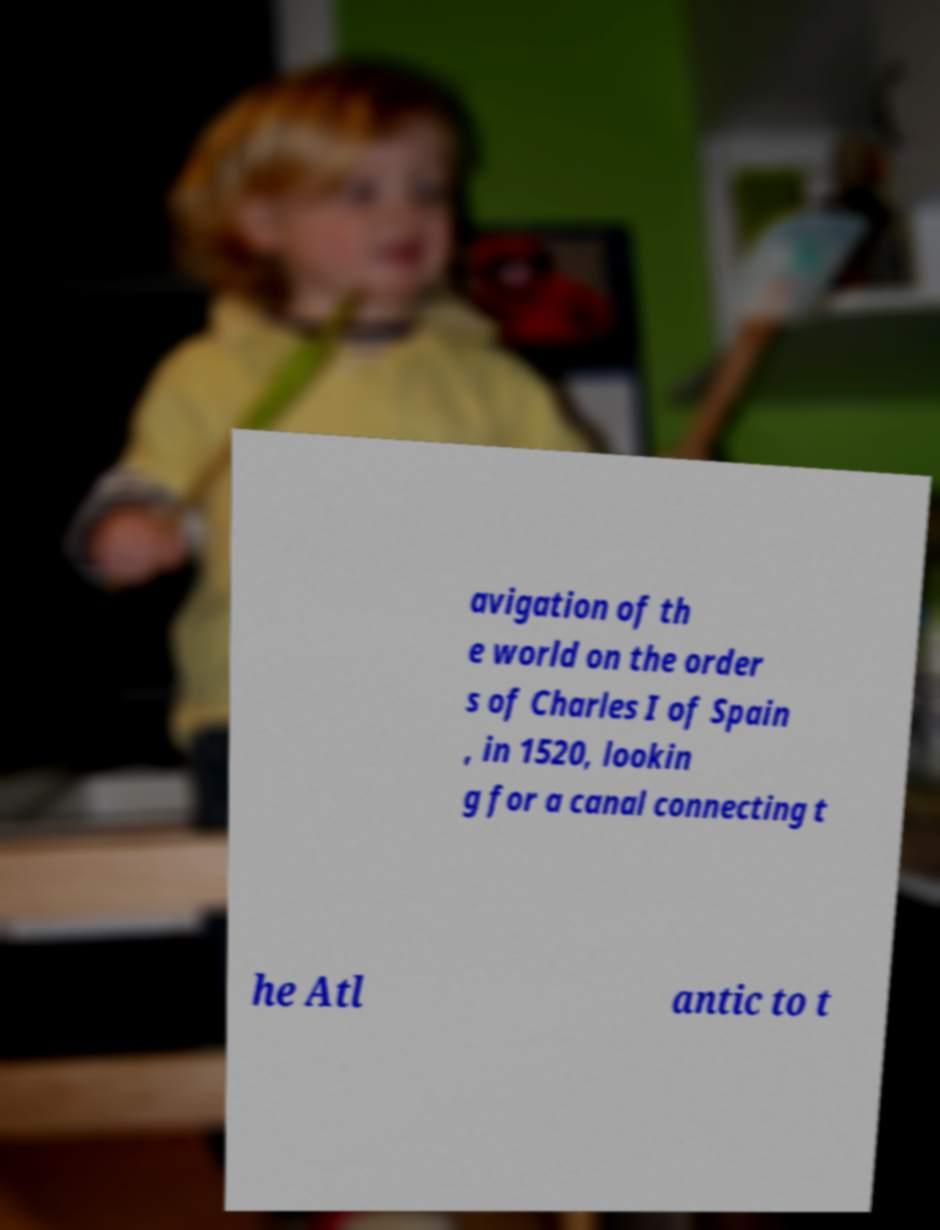I need the written content from this picture converted into text. Can you do that? avigation of th e world on the order s of Charles I of Spain , in 1520, lookin g for a canal connecting t he Atl antic to t 